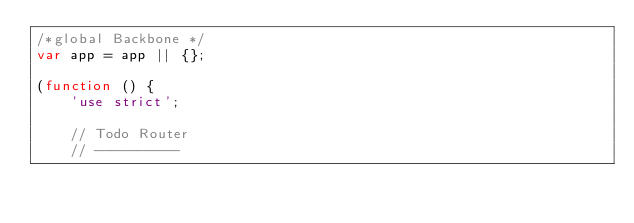<code> <loc_0><loc_0><loc_500><loc_500><_JavaScript_>/*global Backbone */
var app = app || {};

(function () {
	'use strict';

	// Todo Router
	// ----------</code> 